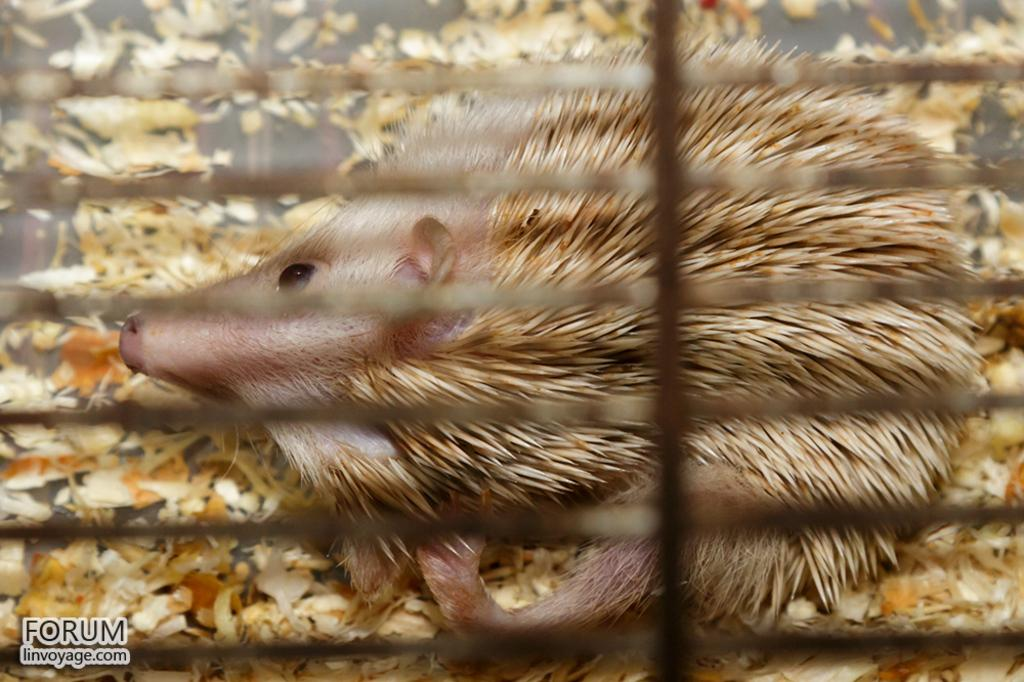What type of animal is in the image? There is a porcupine in the image. What else can be seen in the image besides the porcupine? There are leaves and a grille in the image. Can you tell me how many berries the porcupine is holding in the image? There are no berries present in the image; it only features a porcupine, leaves, and a grille. What type of muscle is visible on the porcupine in the image? There is no muscle visible on the porcupine in the image, as it is a porcupine and not a human or animal with visible muscles. 